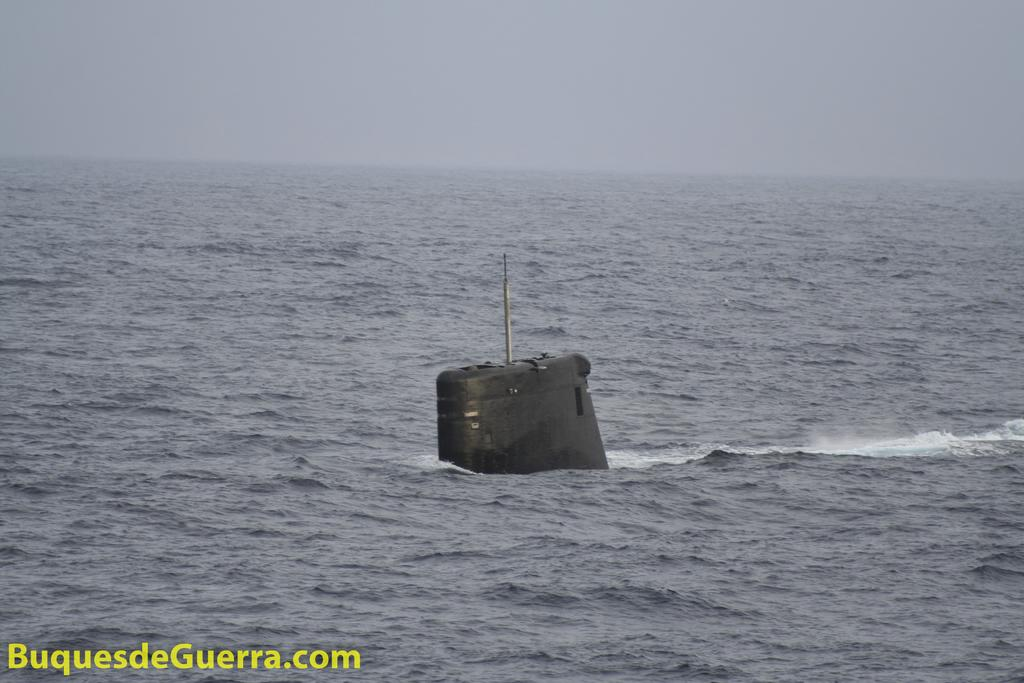What is the main object in the middle of the image? There is a black color object in the middle of the image, which might be a ship. What is the surrounding environment of the object? There is water visible at the bottom of the image, which might be in the sea. What is visible at the top of the image? The sky is visible at the top of the image. Can you see any magic happening around the ship in the image? There is no magic present in the image; it is a realistic depiction of a ship in the sea. Is there a robin perched on the ship's mast in the image? There is no robin present in the image; the focus is on the ship and its surroundings. 